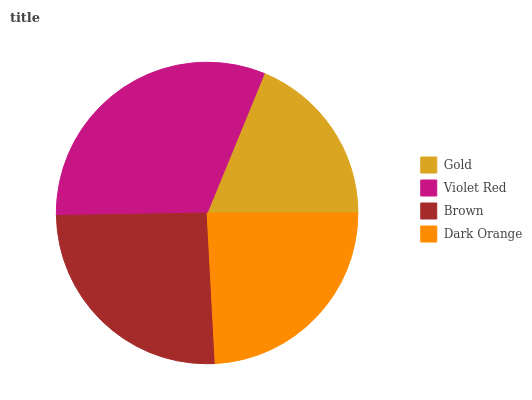Is Gold the minimum?
Answer yes or no. Yes. Is Violet Red the maximum?
Answer yes or no. Yes. Is Brown the minimum?
Answer yes or no. No. Is Brown the maximum?
Answer yes or no. No. Is Violet Red greater than Brown?
Answer yes or no. Yes. Is Brown less than Violet Red?
Answer yes or no. Yes. Is Brown greater than Violet Red?
Answer yes or no. No. Is Violet Red less than Brown?
Answer yes or no. No. Is Brown the high median?
Answer yes or no. Yes. Is Dark Orange the low median?
Answer yes or no. Yes. Is Gold the high median?
Answer yes or no. No. Is Brown the low median?
Answer yes or no. No. 